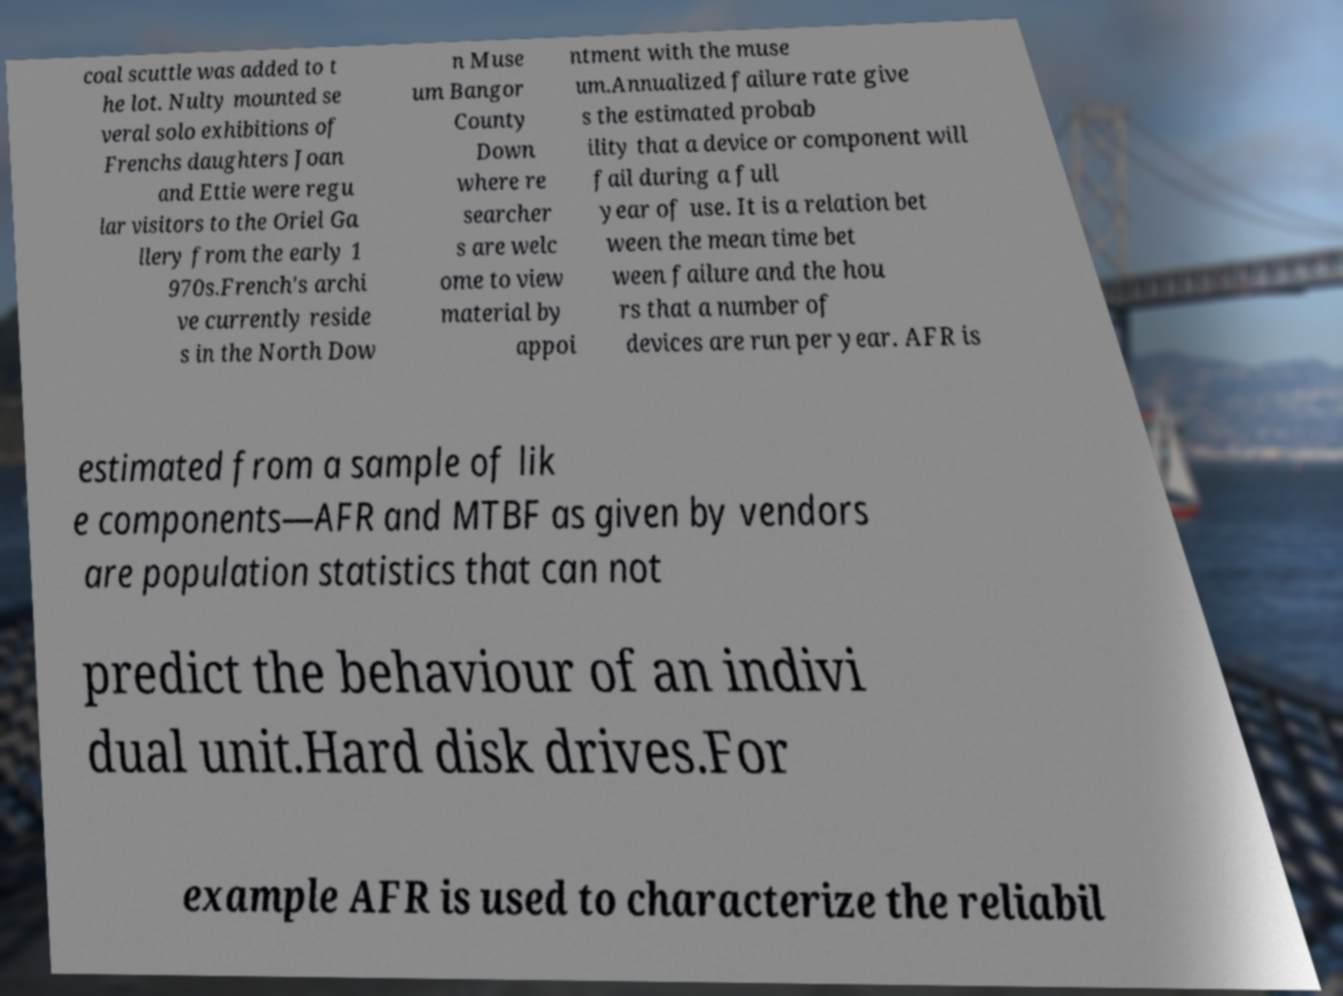For documentation purposes, I need the text within this image transcribed. Could you provide that? coal scuttle was added to t he lot. Nulty mounted se veral solo exhibitions of Frenchs daughters Joan and Ettie were regu lar visitors to the Oriel Ga llery from the early 1 970s.French's archi ve currently reside s in the North Dow n Muse um Bangor County Down where re searcher s are welc ome to view material by appoi ntment with the muse um.Annualized failure rate give s the estimated probab ility that a device or component will fail during a full year of use. It is a relation bet ween the mean time bet ween failure and the hou rs that a number of devices are run per year. AFR is estimated from a sample of lik e components—AFR and MTBF as given by vendors are population statistics that can not predict the behaviour of an indivi dual unit.Hard disk drives.For example AFR is used to characterize the reliabil 